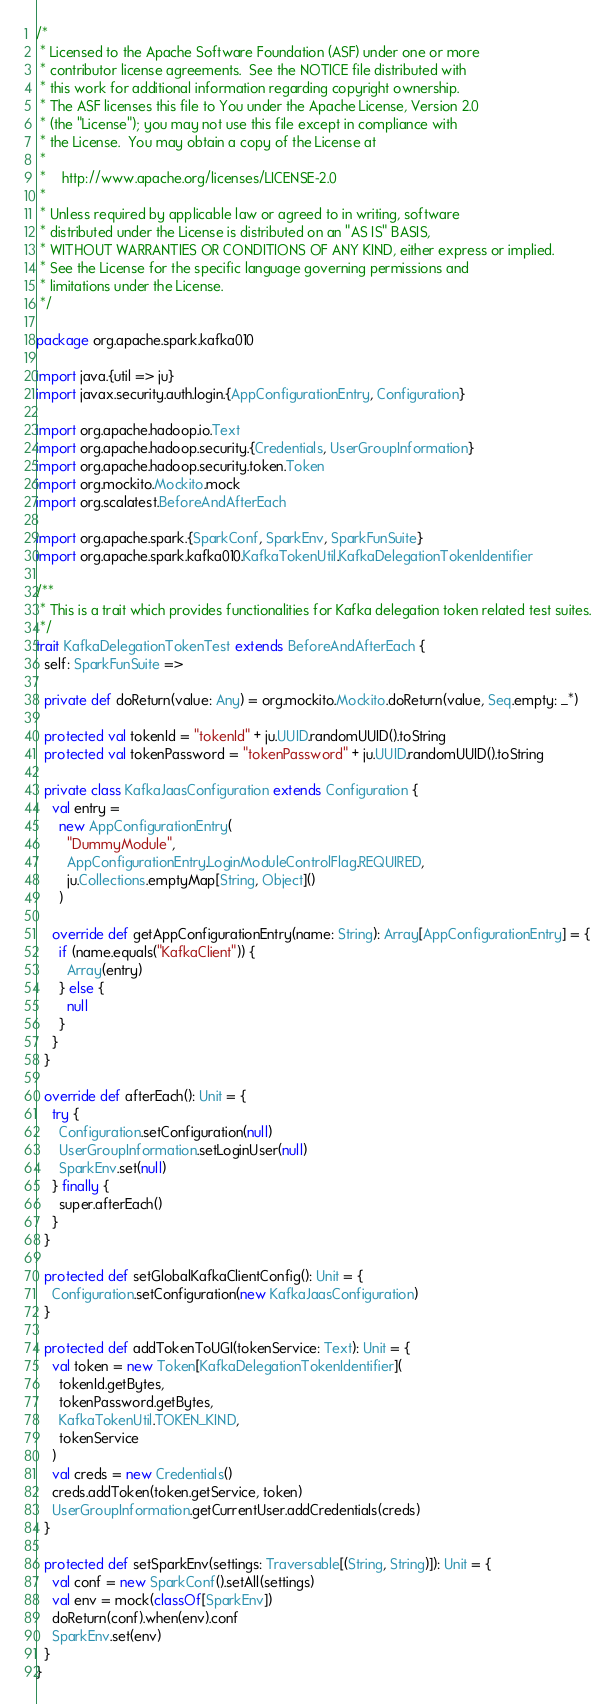<code> <loc_0><loc_0><loc_500><loc_500><_Scala_>/*
 * Licensed to the Apache Software Foundation (ASF) under one or more
 * contributor license agreements.  See the NOTICE file distributed with
 * this work for additional information regarding copyright ownership.
 * The ASF licenses this file to You under the Apache License, Version 2.0
 * (the "License"); you may not use this file except in compliance with
 * the License.  You may obtain a copy of the License at
 *
 *    http://www.apache.org/licenses/LICENSE-2.0
 *
 * Unless required by applicable law or agreed to in writing, software
 * distributed under the License is distributed on an "AS IS" BASIS,
 * WITHOUT WARRANTIES OR CONDITIONS OF ANY KIND, either express or implied.
 * See the License for the specific language governing permissions and
 * limitations under the License.
 */

package org.apache.spark.kafka010

import java.{util => ju}
import javax.security.auth.login.{AppConfigurationEntry, Configuration}

import org.apache.hadoop.io.Text
import org.apache.hadoop.security.{Credentials, UserGroupInformation}
import org.apache.hadoop.security.token.Token
import org.mockito.Mockito.mock
import org.scalatest.BeforeAndAfterEach

import org.apache.spark.{SparkConf, SparkEnv, SparkFunSuite}
import org.apache.spark.kafka010.KafkaTokenUtil.KafkaDelegationTokenIdentifier

/**
 * This is a trait which provides functionalities for Kafka delegation token related test suites.
 */
trait KafkaDelegationTokenTest extends BeforeAndAfterEach {
  self: SparkFunSuite =>

  private def doReturn(value: Any) = org.mockito.Mockito.doReturn(value, Seq.empty: _*)

  protected val tokenId = "tokenId" + ju.UUID.randomUUID().toString
  protected val tokenPassword = "tokenPassword" + ju.UUID.randomUUID().toString

  private class KafkaJaasConfiguration extends Configuration {
    val entry =
      new AppConfigurationEntry(
        "DummyModule",
        AppConfigurationEntry.LoginModuleControlFlag.REQUIRED,
        ju.Collections.emptyMap[String, Object]()
      )

    override def getAppConfigurationEntry(name: String): Array[AppConfigurationEntry] = {
      if (name.equals("KafkaClient")) {
        Array(entry)
      } else {
        null
      }
    }
  }

  override def afterEach(): Unit = {
    try {
      Configuration.setConfiguration(null)
      UserGroupInformation.setLoginUser(null)
      SparkEnv.set(null)
    } finally {
      super.afterEach()
    }
  }

  protected def setGlobalKafkaClientConfig(): Unit = {
    Configuration.setConfiguration(new KafkaJaasConfiguration)
  }

  protected def addTokenToUGI(tokenService: Text): Unit = {
    val token = new Token[KafkaDelegationTokenIdentifier](
      tokenId.getBytes,
      tokenPassword.getBytes,
      KafkaTokenUtil.TOKEN_KIND,
      tokenService
    )
    val creds = new Credentials()
    creds.addToken(token.getService, token)
    UserGroupInformation.getCurrentUser.addCredentials(creds)
  }

  protected def setSparkEnv(settings: Traversable[(String, String)]): Unit = {
    val conf = new SparkConf().setAll(settings)
    val env = mock(classOf[SparkEnv])
    doReturn(conf).when(env).conf
    SparkEnv.set(env)
  }
}
</code> 